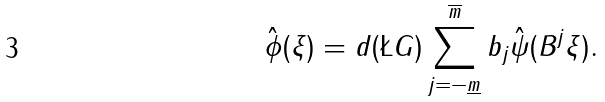Convert formula to latex. <formula><loc_0><loc_0><loc_500><loc_500>\hat { \phi } ( \xi ) = d ( \L G ) \sum _ { j = - \underline { m } } ^ { \overline { m } } b _ { j } \hat { \psi } ( B ^ { j } \xi ) .</formula> 